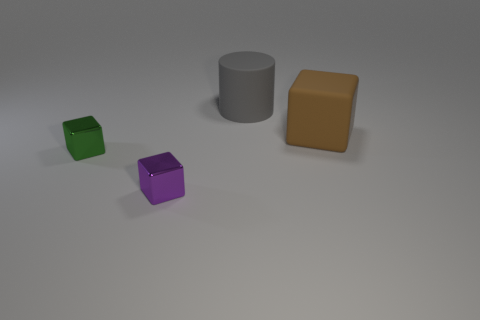There is a thing that is the same size as the brown block; what is its material?
Give a very brief answer. Rubber. Are there any other green objects that have the same size as the green metal thing?
Provide a short and direct response. No. Is the number of brown cubes behind the gray rubber cylinder the same as the number of large gray rubber cylinders that are left of the small green metal thing?
Provide a succinct answer. Yes. Are there more purple cubes than tiny metallic objects?
Your response must be concise. No. What number of metal objects are small purple objects or tiny yellow cylinders?
Your answer should be very brief. 1. What number of small shiny things have the same color as the rubber block?
Your response must be concise. 0. What material is the large thing on the right side of the big rubber object behind the large object that is in front of the big cylinder?
Make the answer very short. Rubber. There is a shiny thing that is behind the tiny metal block in front of the tiny green object; what color is it?
Make the answer very short. Green. What number of big things are purple metallic things or green metallic cylinders?
Give a very brief answer. 0. How many big cylinders have the same material as the big brown block?
Provide a short and direct response. 1. 